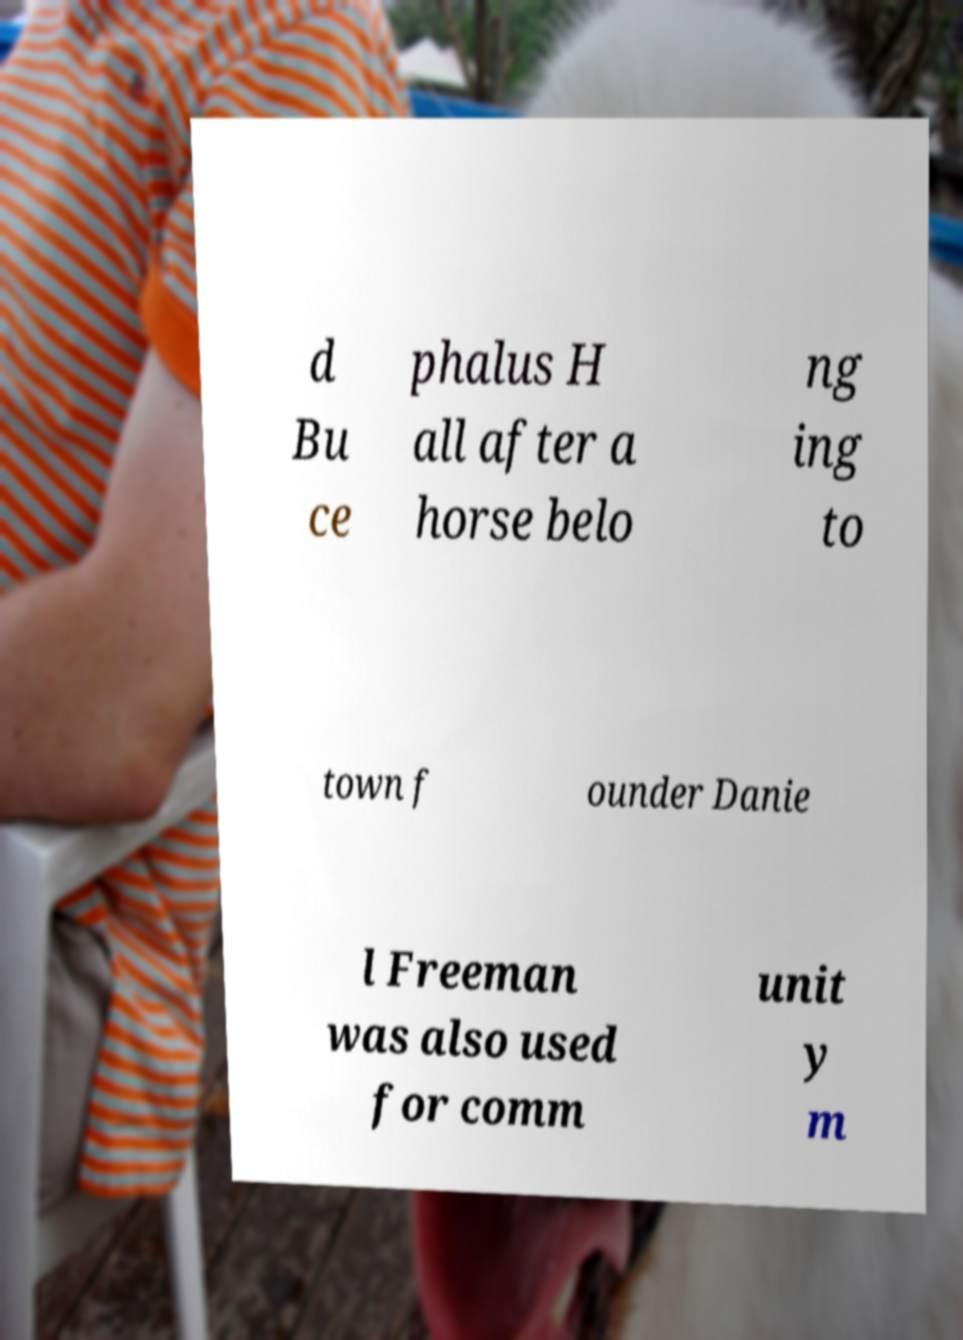Can you read and provide the text displayed in the image?This photo seems to have some interesting text. Can you extract and type it out for me? d Bu ce phalus H all after a horse belo ng ing to town f ounder Danie l Freeman was also used for comm unit y m 